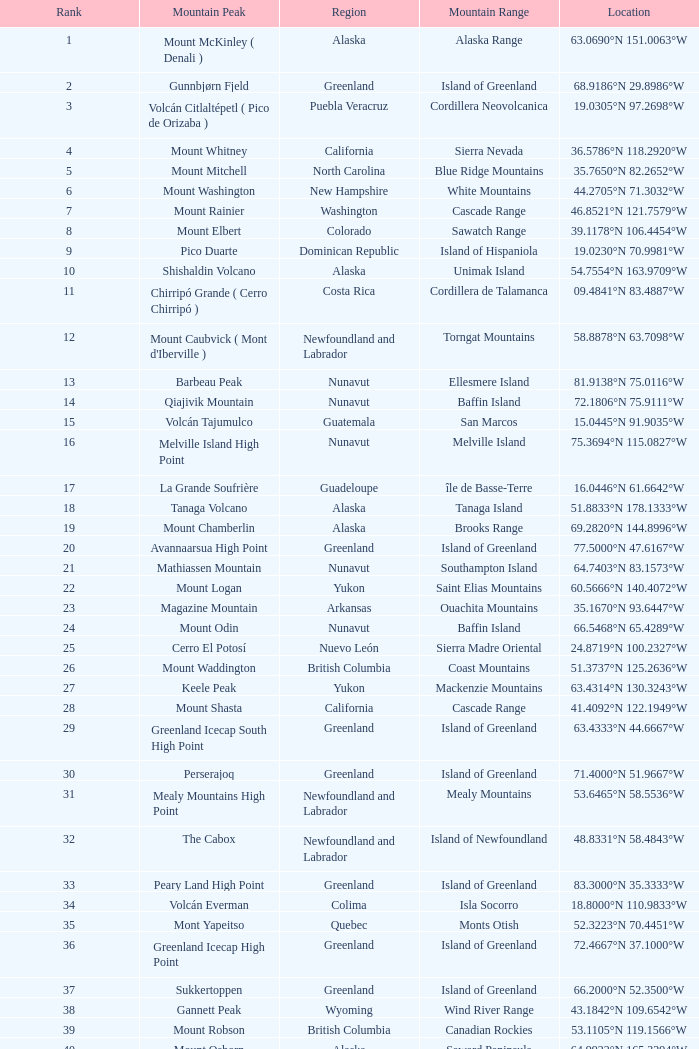Name the Mountain Peak which has a Rank of 62? Cerro Nube ( Quie Yelaag ). 